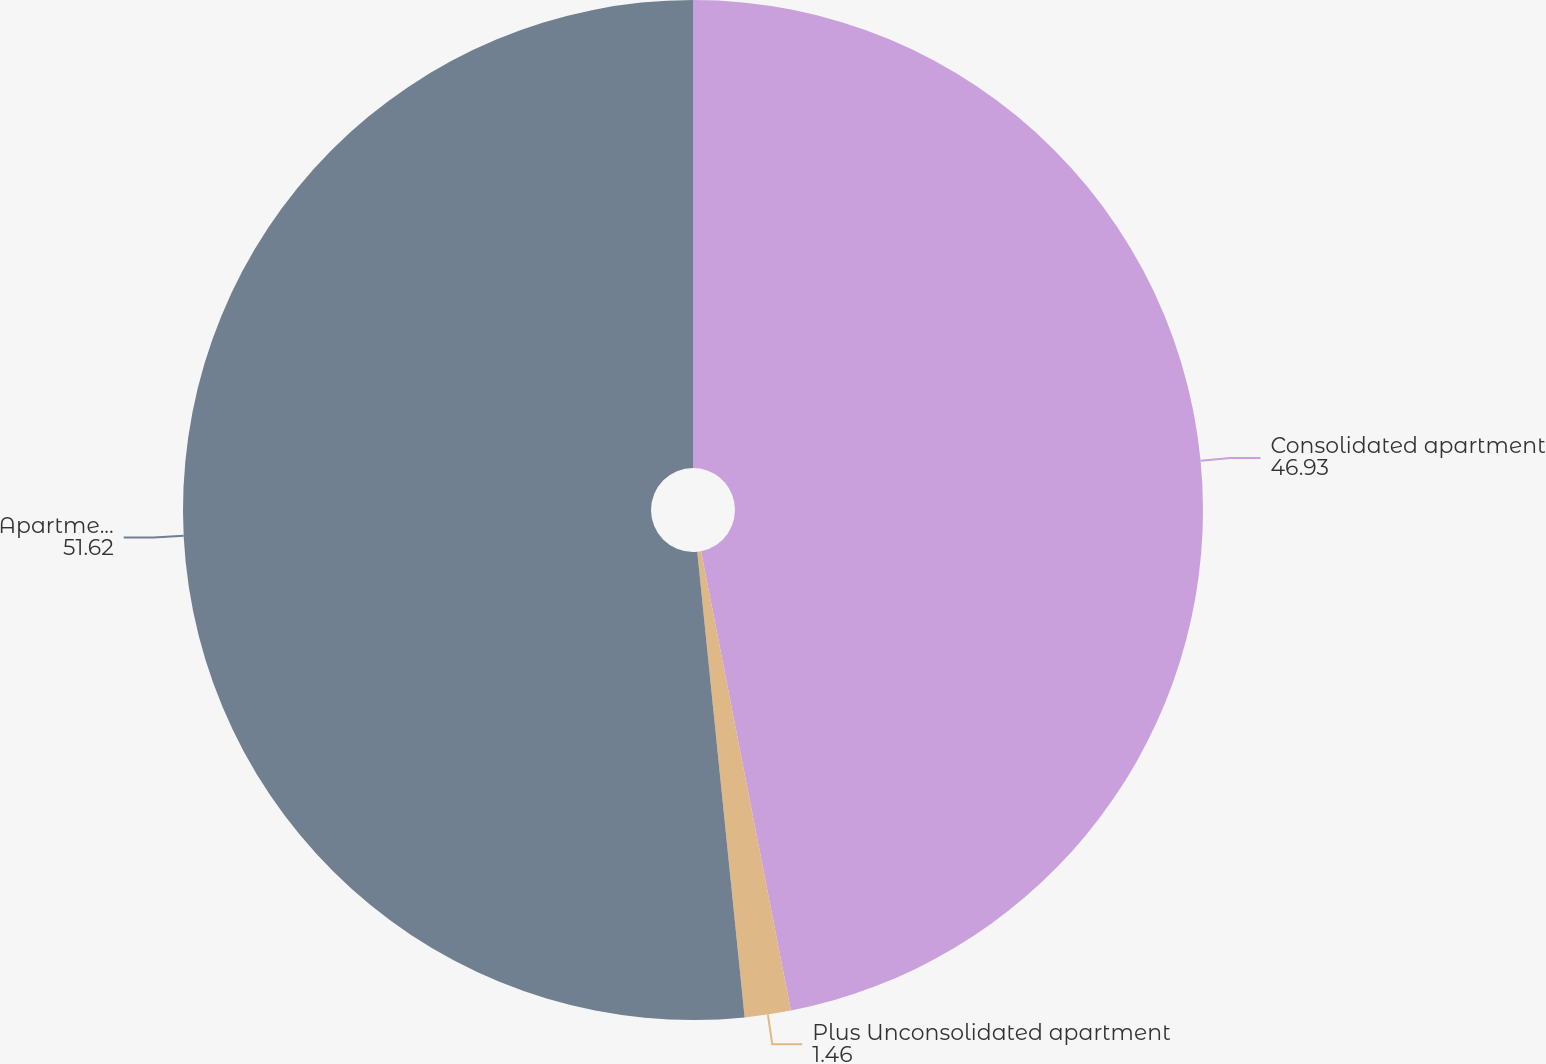Convert chart. <chart><loc_0><loc_0><loc_500><loc_500><pie_chart><fcel>Consolidated apartment<fcel>Plus Unconsolidated apartment<fcel>Apartment communities in total<nl><fcel>46.93%<fcel>1.46%<fcel>51.62%<nl></chart> 